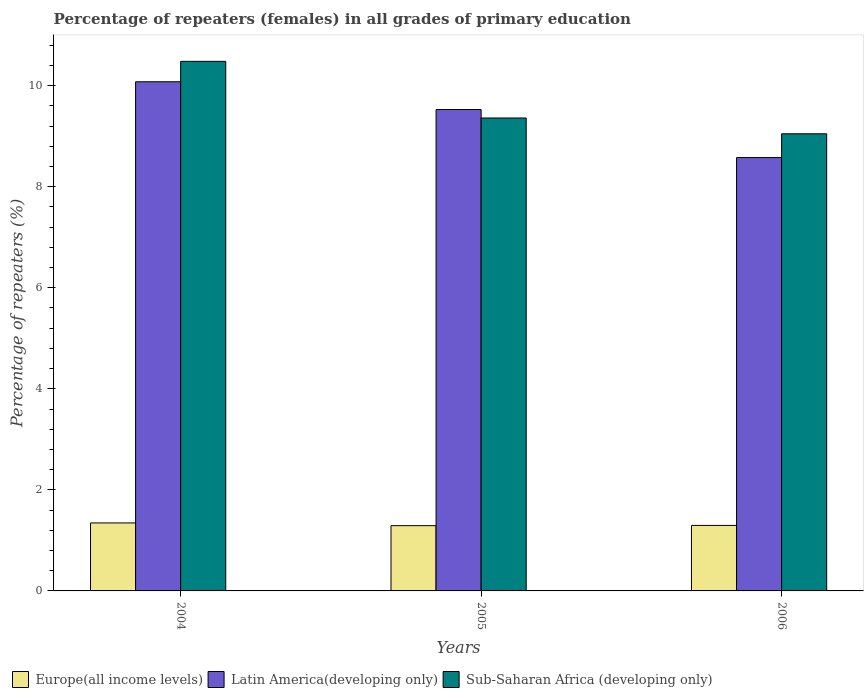How many different coloured bars are there?
Your answer should be very brief. 3. Are the number of bars per tick equal to the number of legend labels?
Provide a short and direct response. Yes. Are the number of bars on each tick of the X-axis equal?
Ensure brevity in your answer.  Yes. How many bars are there on the 1st tick from the left?
Offer a terse response. 3. In how many cases, is the number of bars for a given year not equal to the number of legend labels?
Give a very brief answer. 0. What is the percentage of repeaters (females) in Europe(all income levels) in 2005?
Provide a succinct answer. 1.29. Across all years, what is the maximum percentage of repeaters (females) in Europe(all income levels)?
Provide a succinct answer. 1.35. Across all years, what is the minimum percentage of repeaters (females) in Sub-Saharan Africa (developing only)?
Keep it short and to the point. 9.05. What is the total percentage of repeaters (females) in Sub-Saharan Africa (developing only) in the graph?
Provide a succinct answer. 28.89. What is the difference between the percentage of repeaters (females) in Europe(all income levels) in 2004 and that in 2006?
Provide a short and direct response. 0.05. What is the difference between the percentage of repeaters (females) in Latin America(developing only) in 2005 and the percentage of repeaters (females) in Europe(all income levels) in 2004?
Your response must be concise. 8.18. What is the average percentage of repeaters (females) in Sub-Saharan Africa (developing only) per year?
Offer a very short reply. 9.63. In the year 2004, what is the difference between the percentage of repeaters (females) in Europe(all income levels) and percentage of repeaters (females) in Latin America(developing only)?
Ensure brevity in your answer.  -8.73. In how many years, is the percentage of repeaters (females) in Sub-Saharan Africa (developing only) greater than 3.6 %?
Keep it short and to the point. 3. What is the ratio of the percentage of repeaters (females) in Latin America(developing only) in 2004 to that in 2005?
Give a very brief answer. 1.06. Is the difference between the percentage of repeaters (females) in Europe(all income levels) in 2005 and 2006 greater than the difference between the percentage of repeaters (females) in Latin America(developing only) in 2005 and 2006?
Keep it short and to the point. No. What is the difference between the highest and the second highest percentage of repeaters (females) in Sub-Saharan Africa (developing only)?
Your answer should be very brief. 1.12. What is the difference between the highest and the lowest percentage of repeaters (females) in Sub-Saharan Africa (developing only)?
Provide a succinct answer. 1.43. Is the sum of the percentage of repeaters (females) in Sub-Saharan Africa (developing only) in 2004 and 2006 greater than the maximum percentage of repeaters (females) in Latin America(developing only) across all years?
Give a very brief answer. Yes. What does the 1st bar from the left in 2006 represents?
Give a very brief answer. Europe(all income levels). What does the 3rd bar from the right in 2005 represents?
Your response must be concise. Europe(all income levels). Is it the case that in every year, the sum of the percentage of repeaters (females) in Europe(all income levels) and percentage of repeaters (females) in Latin America(developing only) is greater than the percentage of repeaters (females) in Sub-Saharan Africa (developing only)?
Offer a terse response. Yes. How many years are there in the graph?
Keep it short and to the point. 3. What is the difference between two consecutive major ticks on the Y-axis?
Provide a short and direct response. 2. Does the graph contain any zero values?
Your response must be concise. No. Does the graph contain grids?
Your response must be concise. No. How many legend labels are there?
Keep it short and to the point. 3. How are the legend labels stacked?
Your answer should be compact. Horizontal. What is the title of the graph?
Your response must be concise. Percentage of repeaters (females) in all grades of primary education. What is the label or title of the Y-axis?
Offer a very short reply. Percentage of repeaters (%). What is the Percentage of repeaters (%) in Europe(all income levels) in 2004?
Give a very brief answer. 1.35. What is the Percentage of repeaters (%) in Latin America(developing only) in 2004?
Offer a very short reply. 10.08. What is the Percentage of repeaters (%) in Sub-Saharan Africa (developing only) in 2004?
Provide a short and direct response. 10.48. What is the Percentage of repeaters (%) of Europe(all income levels) in 2005?
Make the answer very short. 1.29. What is the Percentage of repeaters (%) of Latin America(developing only) in 2005?
Keep it short and to the point. 9.53. What is the Percentage of repeaters (%) of Sub-Saharan Africa (developing only) in 2005?
Ensure brevity in your answer.  9.36. What is the Percentage of repeaters (%) in Europe(all income levels) in 2006?
Offer a very short reply. 1.3. What is the Percentage of repeaters (%) of Latin America(developing only) in 2006?
Your answer should be very brief. 8.58. What is the Percentage of repeaters (%) in Sub-Saharan Africa (developing only) in 2006?
Offer a terse response. 9.05. Across all years, what is the maximum Percentage of repeaters (%) of Europe(all income levels)?
Provide a succinct answer. 1.35. Across all years, what is the maximum Percentage of repeaters (%) in Latin America(developing only)?
Ensure brevity in your answer.  10.08. Across all years, what is the maximum Percentage of repeaters (%) of Sub-Saharan Africa (developing only)?
Your answer should be compact. 10.48. Across all years, what is the minimum Percentage of repeaters (%) in Europe(all income levels)?
Make the answer very short. 1.29. Across all years, what is the minimum Percentage of repeaters (%) in Latin America(developing only)?
Your answer should be very brief. 8.58. Across all years, what is the minimum Percentage of repeaters (%) in Sub-Saharan Africa (developing only)?
Give a very brief answer. 9.05. What is the total Percentage of repeaters (%) in Europe(all income levels) in the graph?
Make the answer very short. 3.93. What is the total Percentage of repeaters (%) of Latin America(developing only) in the graph?
Ensure brevity in your answer.  28.18. What is the total Percentage of repeaters (%) in Sub-Saharan Africa (developing only) in the graph?
Give a very brief answer. 28.89. What is the difference between the Percentage of repeaters (%) of Europe(all income levels) in 2004 and that in 2005?
Make the answer very short. 0.05. What is the difference between the Percentage of repeaters (%) in Latin America(developing only) in 2004 and that in 2005?
Keep it short and to the point. 0.55. What is the difference between the Percentage of repeaters (%) in Sub-Saharan Africa (developing only) in 2004 and that in 2005?
Keep it short and to the point. 1.12. What is the difference between the Percentage of repeaters (%) in Europe(all income levels) in 2004 and that in 2006?
Provide a short and direct response. 0.05. What is the difference between the Percentage of repeaters (%) of Latin America(developing only) in 2004 and that in 2006?
Your answer should be very brief. 1.5. What is the difference between the Percentage of repeaters (%) in Sub-Saharan Africa (developing only) in 2004 and that in 2006?
Give a very brief answer. 1.43. What is the difference between the Percentage of repeaters (%) in Europe(all income levels) in 2005 and that in 2006?
Give a very brief answer. -0. What is the difference between the Percentage of repeaters (%) of Latin America(developing only) in 2005 and that in 2006?
Offer a very short reply. 0.95. What is the difference between the Percentage of repeaters (%) in Sub-Saharan Africa (developing only) in 2005 and that in 2006?
Your answer should be compact. 0.31. What is the difference between the Percentage of repeaters (%) of Europe(all income levels) in 2004 and the Percentage of repeaters (%) of Latin America(developing only) in 2005?
Offer a very short reply. -8.18. What is the difference between the Percentage of repeaters (%) of Europe(all income levels) in 2004 and the Percentage of repeaters (%) of Sub-Saharan Africa (developing only) in 2005?
Give a very brief answer. -8.01. What is the difference between the Percentage of repeaters (%) of Latin America(developing only) in 2004 and the Percentage of repeaters (%) of Sub-Saharan Africa (developing only) in 2005?
Offer a very short reply. 0.72. What is the difference between the Percentage of repeaters (%) of Europe(all income levels) in 2004 and the Percentage of repeaters (%) of Latin America(developing only) in 2006?
Your response must be concise. -7.23. What is the difference between the Percentage of repeaters (%) in Europe(all income levels) in 2004 and the Percentage of repeaters (%) in Sub-Saharan Africa (developing only) in 2006?
Provide a short and direct response. -7.7. What is the difference between the Percentage of repeaters (%) in Latin America(developing only) in 2004 and the Percentage of repeaters (%) in Sub-Saharan Africa (developing only) in 2006?
Your response must be concise. 1.03. What is the difference between the Percentage of repeaters (%) in Europe(all income levels) in 2005 and the Percentage of repeaters (%) in Latin America(developing only) in 2006?
Your response must be concise. -7.28. What is the difference between the Percentage of repeaters (%) of Europe(all income levels) in 2005 and the Percentage of repeaters (%) of Sub-Saharan Africa (developing only) in 2006?
Make the answer very short. -7.76. What is the difference between the Percentage of repeaters (%) in Latin America(developing only) in 2005 and the Percentage of repeaters (%) in Sub-Saharan Africa (developing only) in 2006?
Make the answer very short. 0.48. What is the average Percentage of repeaters (%) in Europe(all income levels) per year?
Offer a terse response. 1.31. What is the average Percentage of repeaters (%) of Latin America(developing only) per year?
Your answer should be compact. 9.39. What is the average Percentage of repeaters (%) in Sub-Saharan Africa (developing only) per year?
Ensure brevity in your answer.  9.63. In the year 2004, what is the difference between the Percentage of repeaters (%) in Europe(all income levels) and Percentage of repeaters (%) in Latin America(developing only)?
Your response must be concise. -8.73. In the year 2004, what is the difference between the Percentage of repeaters (%) of Europe(all income levels) and Percentage of repeaters (%) of Sub-Saharan Africa (developing only)?
Offer a very short reply. -9.13. In the year 2004, what is the difference between the Percentage of repeaters (%) of Latin America(developing only) and Percentage of repeaters (%) of Sub-Saharan Africa (developing only)?
Offer a terse response. -0.4. In the year 2005, what is the difference between the Percentage of repeaters (%) in Europe(all income levels) and Percentage of repeaters (%) in Latin America(developing only)?
Offer a terse response. -8.24. In the year 2005, what is the difference between the Percentage of repeaters (%) of Europe(all income levels) and Percentage of repeaters (%) of Sub-Saharan Africa (developing only)?
Ensure brevity in your answer.  -8.07. In the year 2005, what is the difference between the Percentage of repeaters (%) of Latin America(developing only) and Percentage of repeaters (%) of Sub-Saharan Africa (developing only)?
Your response must be concise. 0.17. In the year 2006, what is the difference between the Percentage of repeaters (%) of Europe(all income levels) and Percentage of repeaters (%) of Latin America(developing only)?
Provide a succinct answer. -7.28. In the year 2006, what is the difference between the Percentage of repeaters (%) in Europe(all income levels) and Percentage of repeaters (%) in Sub-Saharan Africa (developing only)?
Your answer should be very brief. -7.75. In the year 2006, what is the difference between the Percentage of repeaters (%) of Latin America(developing only) and Percentage of repeaters (%) of Sub-Saharan Africa (developing only)?
Keep it short and to the point. -0.47. What is the ratio of the Percentage of repeaters (%) of Europe(all income levels) in 2004 to that in 2005?
Keep it short and to the point. 1.04. What is the ratio of the Percentage of repeaters (%) of Latin America(developing only) in 2004 to that in 2005?
Your answer should be compact. 1.06. What is the ratio of the Percentage of repeaters (%) of Sub-Saharan Africa (developing only) in 2004 to that in 2005?
Give a very brief answer. 1.12. What is the ratio of the Percentage of repeaters (%) of Europe(all income levels) in 2004 to that in 2006?
Keep it short and to the point. 1.04. What is the ratio of the Percentage of repeaters (%) in Latin America(developing only) in 2004 to that in 2006?
Keep it short and to the point. 1.18. What is the ratio of the Percentage of repeaters (%) in Sub-Saharan Africa (developing only) in 2004 to that in 2006?
Ensure brevity in your answer.  1.16. What is the ratio of the Percentage of repeaters (%) of Latin America(developing only) in 2005 to that in 2006?
Your answer should be very brief. 1.11. What is the ratio of the Percentage of repeaters (%) in Sub-Saharan Africa (developing only) in 2005 to that in 2006?
Make the answer very short. 1.03. What is the difference between the highest and the second highest Percentage of repeaters (%) of Europe(all income levels)?
Your answer should be compact. 0.05. What is the difference between the highest and the second highest Percentage of repeaters (%) in Latin America(developing only)?
Ensure brevity in your answer.  0.55. What is the difference between the highest and the second highest Percentage of repeaters (%) of Sub-Saharan Africa (developing only)?
Ensure brevity in your answer.  1.12. What is the difference between the highest and the lowest Percentage of repeaters (%) in Europe(all income levels)?
Give a very brief answer. 0.05. What is the difference between the highest and the lowest Percentage of repeaters (%) of Latin America(developing only)?
Your response must be concise. 1.5. What is the difference between the highest and the lowest Percentage of repeaters (%) in Sub-Saharan Africa (developing only)?
Your answer should be very brief. 1.43. 